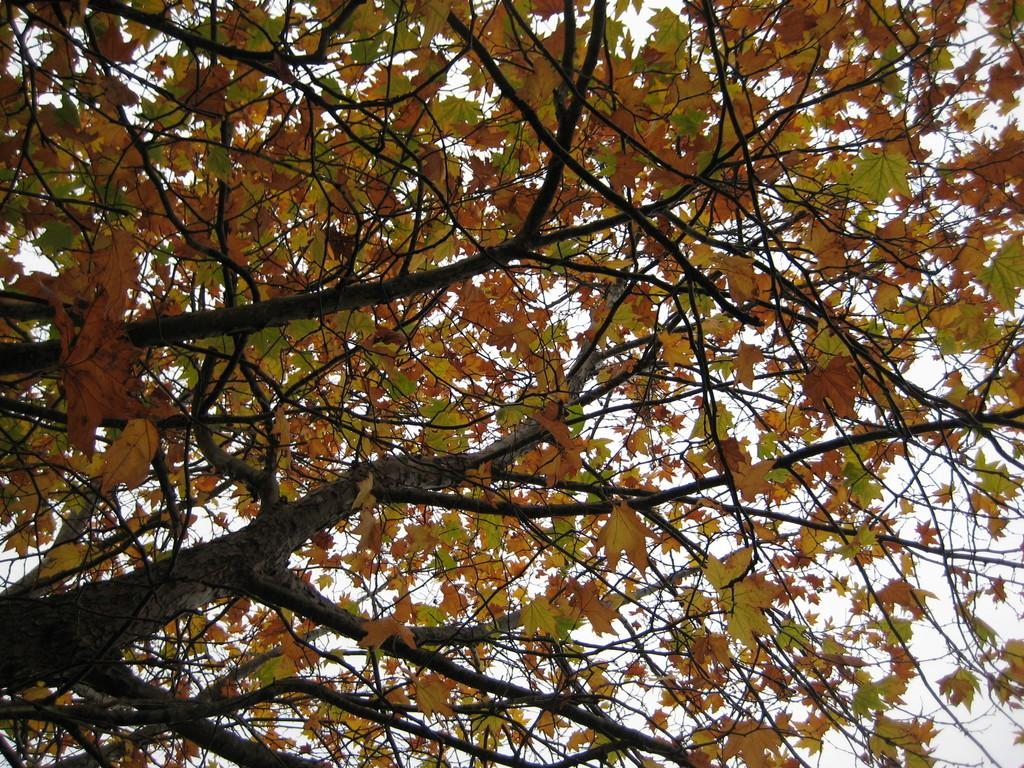What type of vegetation can be seen in the image? There are trees in the image. What part of the natural environment is visible in the image? The sky is visible in the background of the image. What type of celery is being used to decorate the hat in the image? There is no hat or celery present in the image. How are the scissors being used in the image? There are no scissors present in the image. 